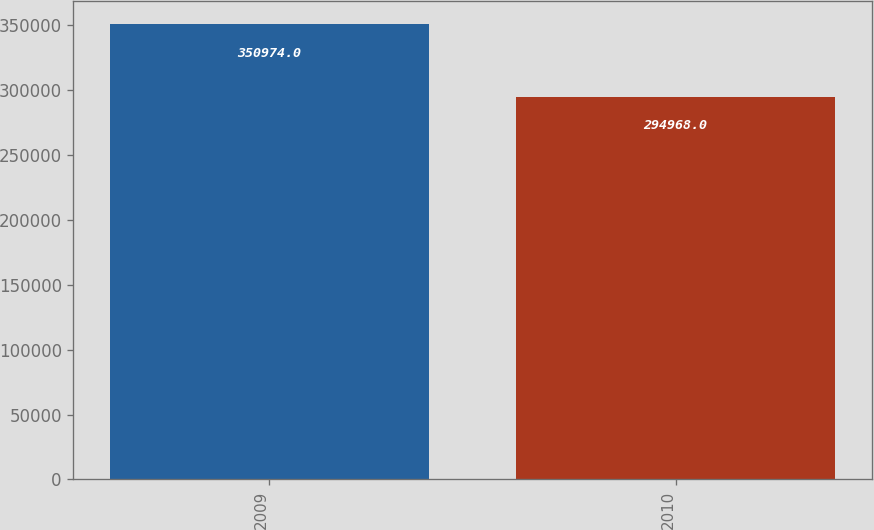Convert chart. <chart><loc_0><loc_0><loc_500><loc_500><bar_chart><fcel>2009<fcel>2010<nl><fcel>350974<fcel>294968<nl></chart> 